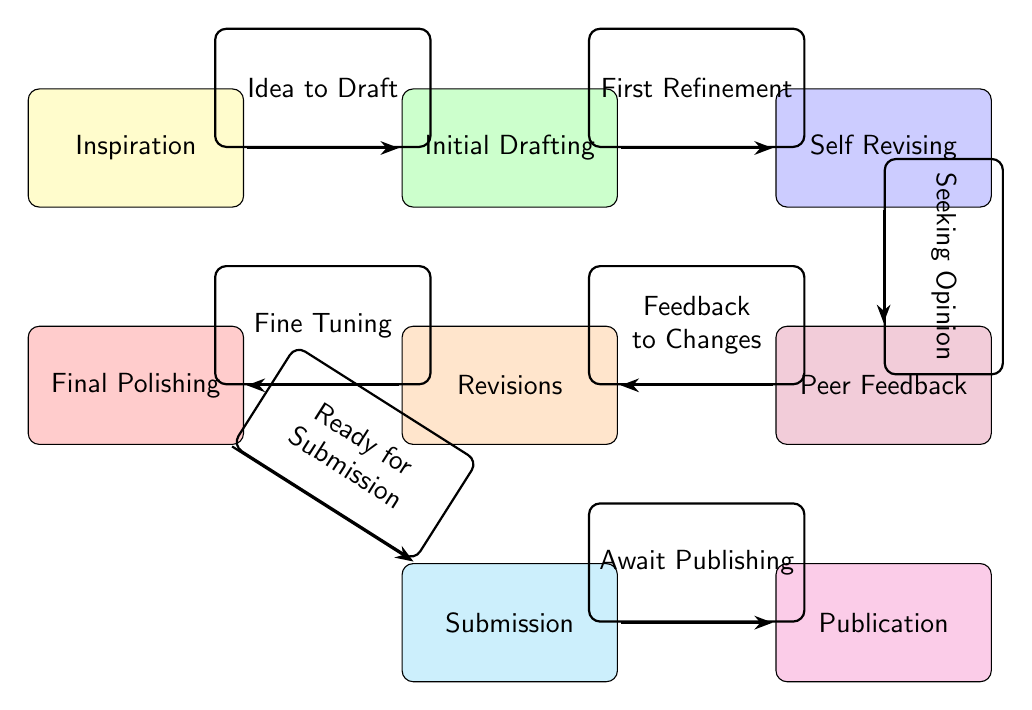What is the first stage of the poem journey? The diagram indicates that the first stage of the journey is labeled as "Inspiration."
Answer: Inspiration How many total stages are depicted in the diagram? Counting the nodes listed in the diagram, there are 7 distinct stages that make up the journey of a poem from inspiration to publication.
Answer: 7 What is the connection between "Peer Feedback" and "Revisions"? The arrow indicates that "Peer Feedback" leads to "Revisions," signifying that feedback from peers results in revision of the draft.
Answer: Revisions Which stage comes immediately after "Self Revising"? The stage that follows "Self Revising" is indicated in the diagram as "Peer Feedback."
Answer: Peer Feedback What action is described between "Initial Drafting" and "Self Revising"? The diagram describes the action between these two stages as "First Refinement," indicating that the initial draft undergoes refinement in this stage.
Answer: First Refinement What is the last stage before "Publication"? According to the diagram, the stage preceding "Publication" is "Submission."
Answer: Submission How does "Final Polishing" relate to "Submission"? The arrow from "Final Polishing" to "Submission" implies that final polishing is what prepares the poem for submission, marking it as ready for that next step.
Answer: Ready for Submission What is the main purpose of the "Feedback to Changes" step? This step indicates how feedback during the "Peer Feedback" stage translates into actual changes made during the "Revisions" stage, highlighting the importance of constructive feedback.
Answer: Feedback to Changes What color denotes the "Inspiration" stage in the diagram? The "Inspiration" stage is highlighted in yellow, which differentiates it visually from other stages in the journey.
Answer: Yellow 